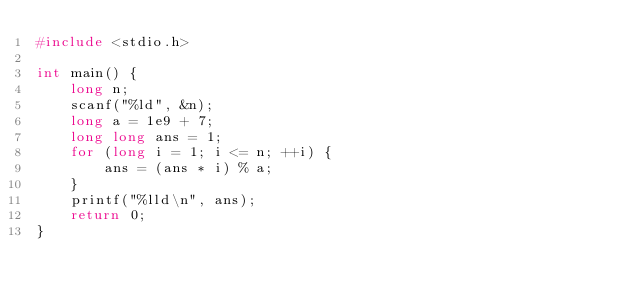Convert code to text. <code><loc_0><loc_0><loc_500><loc_500><_C_>#include <stdio.h>

int main() {
	long n;
	scanf("%ld", &n);
	long a = 1e9 + 7;
	long long ans = 1;
	for (long i = 1; i <= n; ++i) {
		ans = (ans * i) % a;
	}
	printf("%lld\n", ans);
	return 0;
}</code> 